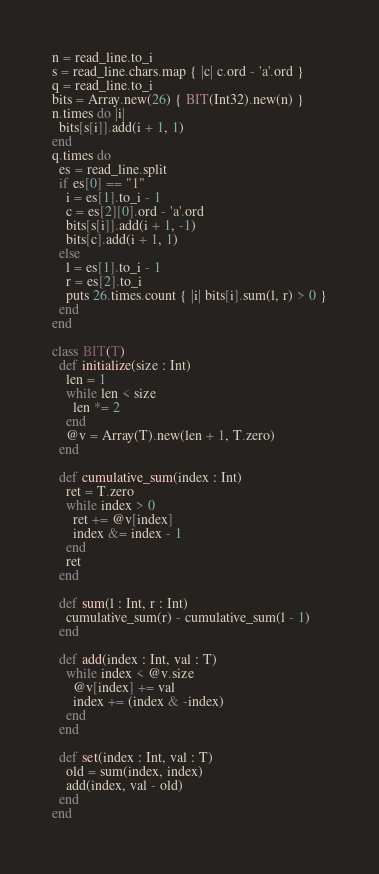Convert code to text. <code><loc_0><loc_0><loc_500><loc_500><_Crystal_>n = read_line.to_i
s = read_line.chars.map { |c| c.ord - 'a'.ord }
q = read_line.to_i
bits = Array.new(26) { BIT(Int32).new(n) }
n.times do |i|
  bits[s[i]].add(i + 1, 1)
end
q.times do
  es = read_line.split
  if es[0] == "1"
    i = es[1].to_i - 1
    c = es[2][0].ord - 'a'.ord
    bits[s[i]].add(i + 1, -1)
    bits[c].add(i + 1, 1)
  else
    l = es[1].to_i - 1
    r = es[2].to_i
    puts 26.times.count { |i| bits[i].sum(l, r) > 0 }
  end
end

class BIT(T)
  def initialize(size : Int)
    len = 1
    while len < size
      len *= 2
    end
    @v = Array(T).new(len + 1, T.zero)
  end

  def cumulative_sum(index : Int)
    ret = T.zero
    while index > 0
      ret += @v[index]
      index &= index - 1
    end
    ret
  end

  def sum(l : Int, r : Int)
    cumulative_sum(r) - cumulative_sum(l - 1)
  end

  def add(index : Int, val : T)
    while index < @v.size
      @v[index] += val
      index += (index & -index)
    end
  end

  def set(index : Int, val : T)
    old = sum(index, index)
    add(index, val - old)
  end
end
</code> 